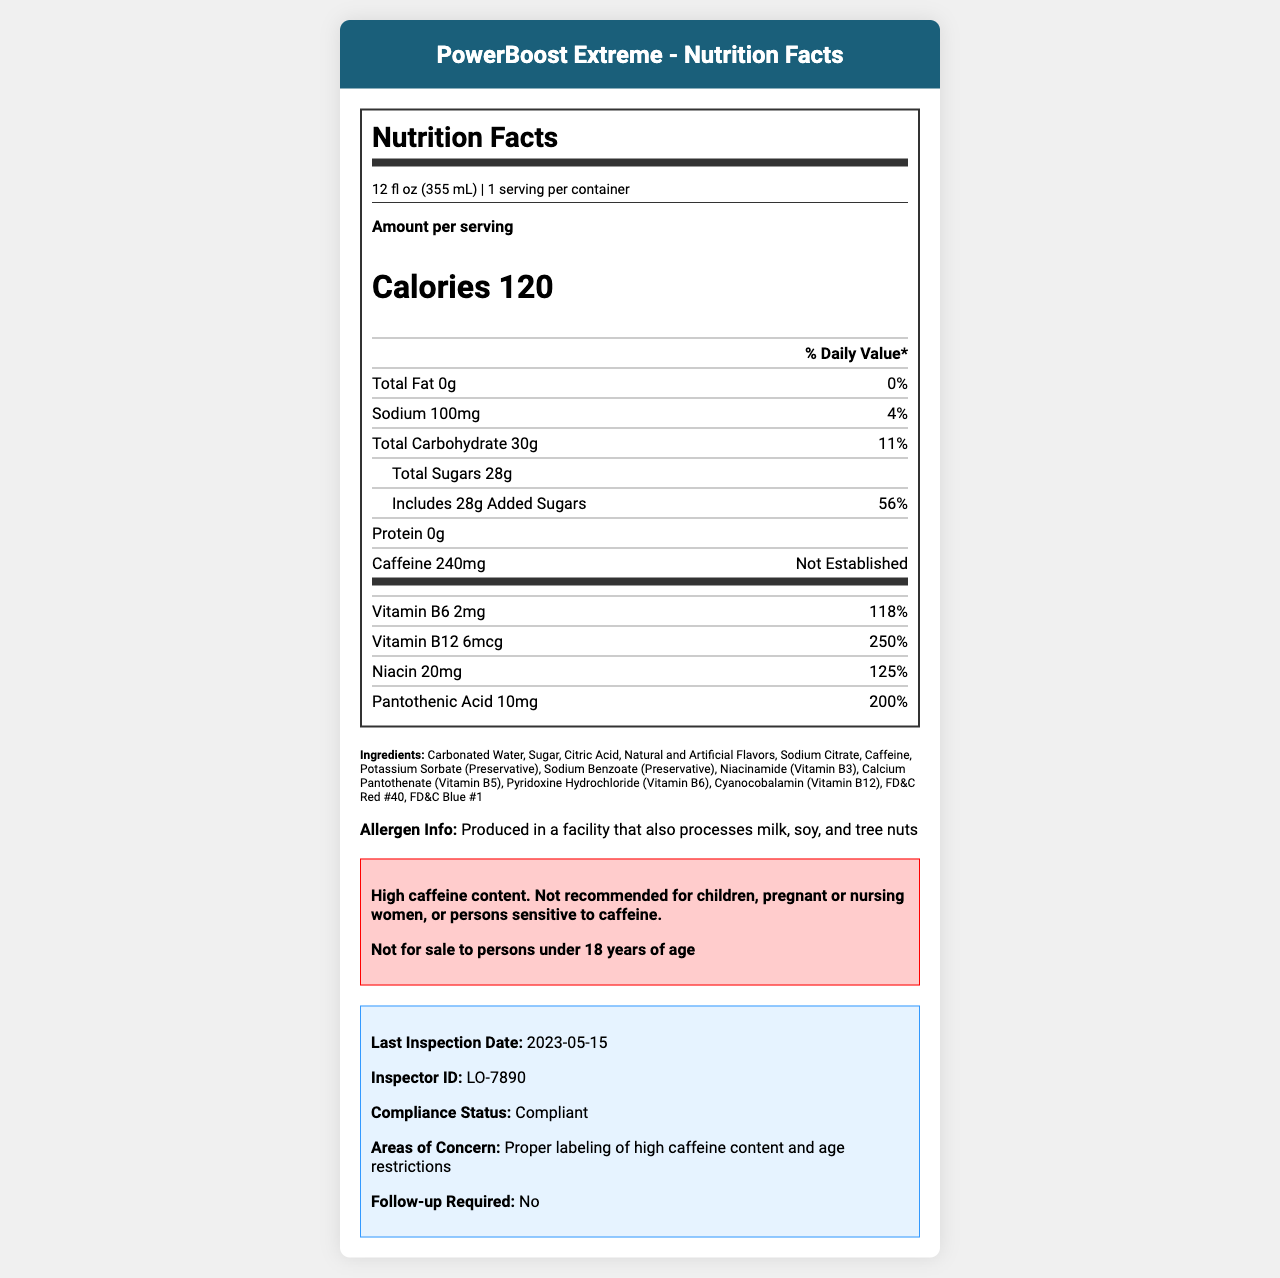What is the serving size of PowerBoost Extreme? The serving size is listed at the top of the nutrition facts section.
Answer: 12 fl oz (355 mL) How many calories are in one serving of PowerBoost Extreme? The number of calories is prominently displayed in the nutrition facts section.
Answer: 120 What percentage of the daily value is provided by the added sugars in PowerBoost Extreme? The added sugars section states that the added sugars account for 56% of the daily value.
Answer: 56% List three vitamins present in PowerBoost Extreme along with their daily value percentages. The vitamins and minerals section lists these vitamins along with their percentages of the daily value.
Answer: Vitamin B6 (118%), Vitamin B12 (250%), Niacin (125%) What is the amount of caffeine in one serving of PowerBoost Extreme? The caffeine amount is listed specifically in the nutrition facts section.
Answer: 240mg Is PowerBoost Extreme recommended for children or pregnant women? The warning section clearly states that it is not recommended for children, pregnant or nursing women, or persons sensitive to caffeine.
Answer: No How much sodium does PowerBoost Extreme contain and what is its daily value percentage? The nutrition facts section provides the sodium content as 100mg and the daily value as 4%.
Answer: 100mg, 4% Multiple Choice: What is the manufacturer of PowerBoost Extreme? A. Energize Beverages, Inc. B. Healthy Drinks Co. C. Active Hydration LLC. The manufacturer is listed at the bottom of the document under the allergen info.
Answer: A. Energize Beverages, Inc. Multiple Choice: Which vitamin has the highest daily value percentage in PowerBoost Extreme? I. Vitamin B6 II. Vitamin B12 III. Niacin IV. Pantothenic Acid Vitamin B12 has the highest daily value percentage at 250%, as listed in the vitamins and minerals section.
Answer: II. Vitamin B12 True/False: PowerBoost Extreme contains any protein. The nutrition facts section lists the protein content as 0g, indicating there is no protein.
Answer: False Summary: Describe the main idea of the PowerBoost Extreme nutrition document. The document is primarily a nutrition label supplemented by regulatory compliance and inspection details, which gives an overview of the drink's nutritional content and safety information.
Answer: The document contains detailed nutrition information for PowerBoost Extreme, including serving size, calories, protein, carbohydrates, fats, vitamins, and minerals. It also provides ingredients, allergen information, warnings about high caffeine content, regulatory compliance details, and inspection notes. What is the FDA Establishment Identifier for PowerBoost Extreme's manufacturer? The FDA registration number is listed under regulatory compliance details in the document.
Answer: FDA Establishment Identifier: 3009876543 Who conducted the last inspection of PowerBoost Extreme, and when did it take place? The inspection notes provide this information.
Answer: Inspector ID: LO-7890, Last inspection date: 2023-05-15 How many servings are there per container of PowerBoost Extreme? The serving info states that there is one serving per container.
Answer: 1 Can the pH level of PowerBoost Extreme be determined from the document? The document does not provide data on the pH level of the drink.
Answer: Not enough information 